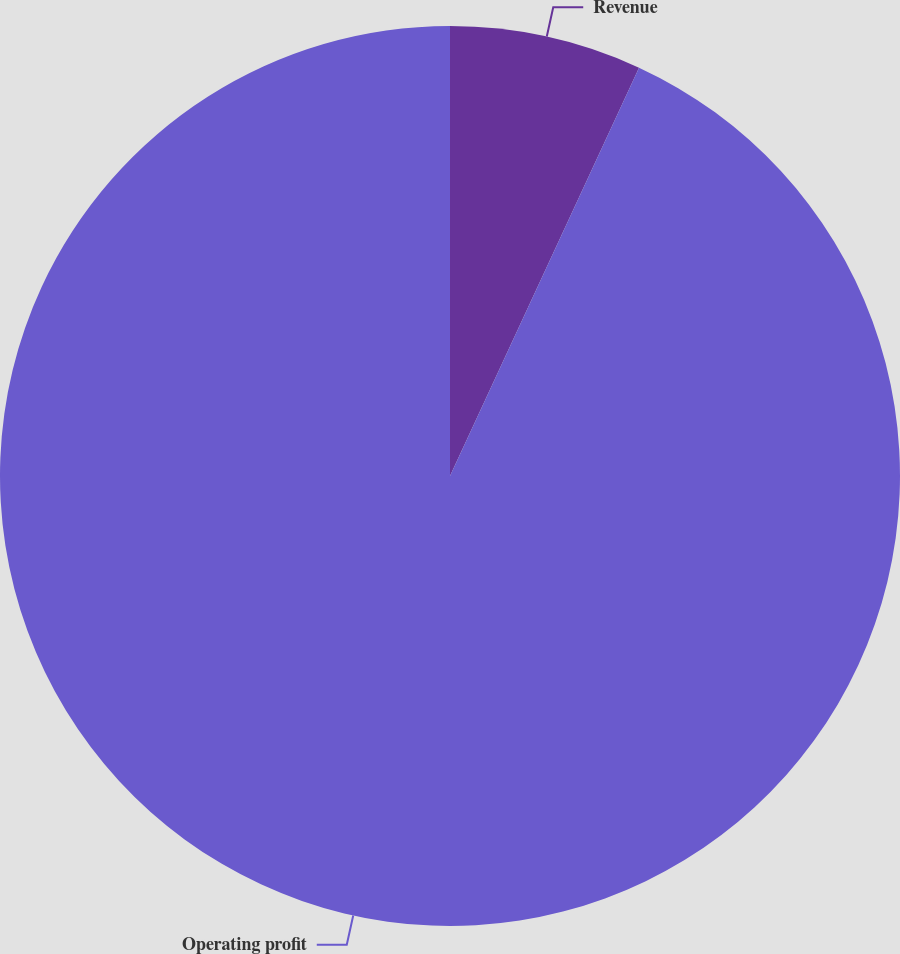<chart> <loc_0><loc_0><loc_500><loc_500><pie_chart><fcel>Revenue<fcel>Operating profit<nl><fcel>6.9%<fcel>93.1%<nl></chart> 